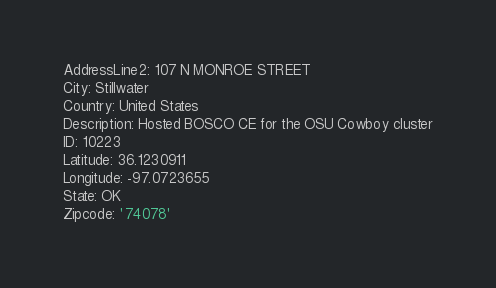Convert code to text. <code><loc_0><loc_0><loc_500><loc_500><_YAML_>AddressLine2: 107 N MONROE STREET
City: Stillwater
Country: United States
Description: Hosted BOSCO CE for the OSU Cowboy cluster
ID: 10223
Latitude: 36.1230911
Longitude: -97.0723655
State: OK
Zipcode: '74078'
</code> 